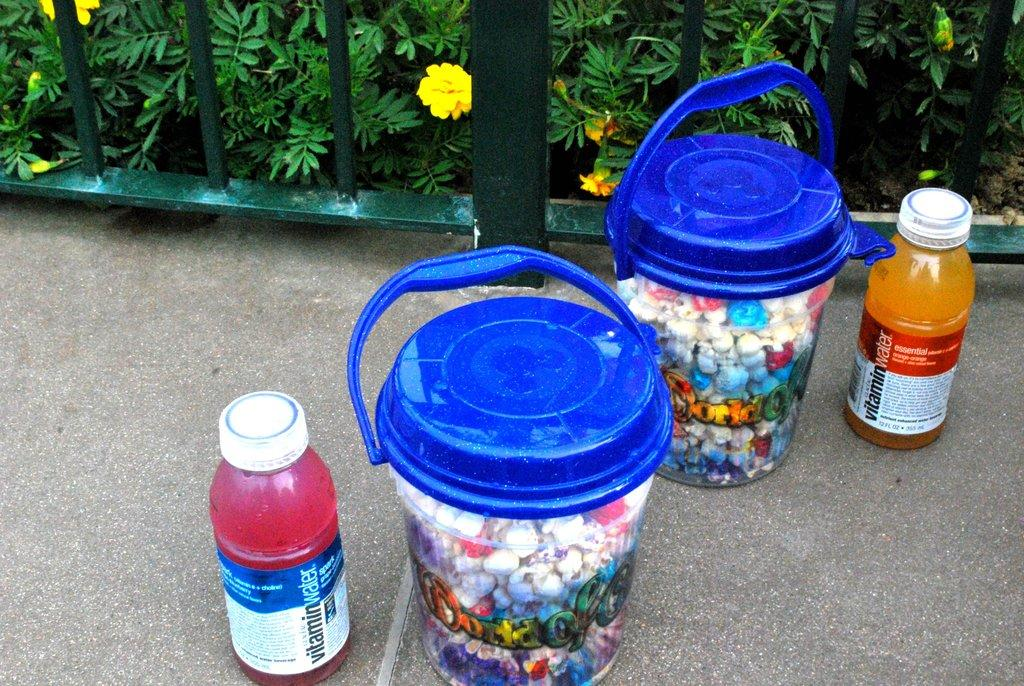<image>
Present a compact description of the photo's key features. Two bottles of Vitamin water next to containers with blue lids. 